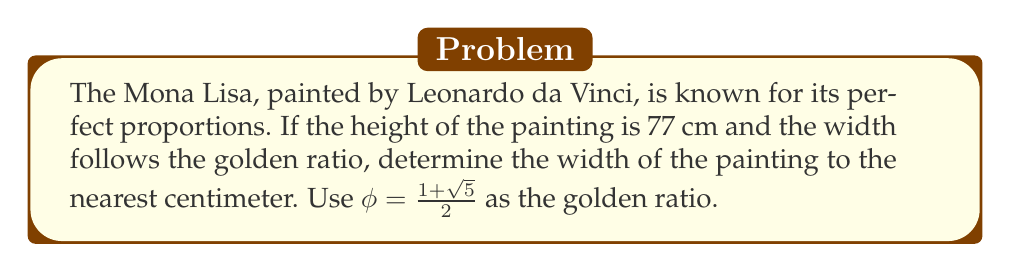Show me your answer to this math problem. To solve this problem, we'll follow these steps:

1) The golden ratio, $\phi$, is defined as the ratio of the longer side to the shorter side. In this case, the height is the longer side.

2) Let's define the width as $w$. We can set up the following equation:

   $$\frac{\text{height}}{\text{width}} = \phi$$

3) Substituting the known values:

   $$\frac{77}{w} = \frac{1+\sqrt{5}}{2}$$

4) To solve for $w$, multiply both sides by $w$:

   $$77 = w \cdot \frac{1+\sqrt{5}}{2}$$

5) Now divide both sides by $\frac{1+\sqrt{5}}{2}$:

   $$w = \frac{77}{\frac{1+\sqrt{5}}{2}}$$

6) Simplify:
   
   $$w = 77 \cdot \frac{2}{1+\sqrt{5}} = \frac{154}{1+\sqrt{5}}$$

7) Use a calculator to evaluate this:

   $$w \approx 47.64 \text{ cm}$$

8) Rounding to the nearest centimeter:

   $$w \approx 48 \text{ cm}$$

Thus, the width of the painting is approximately 48 cm.
Answer: 48 cm 